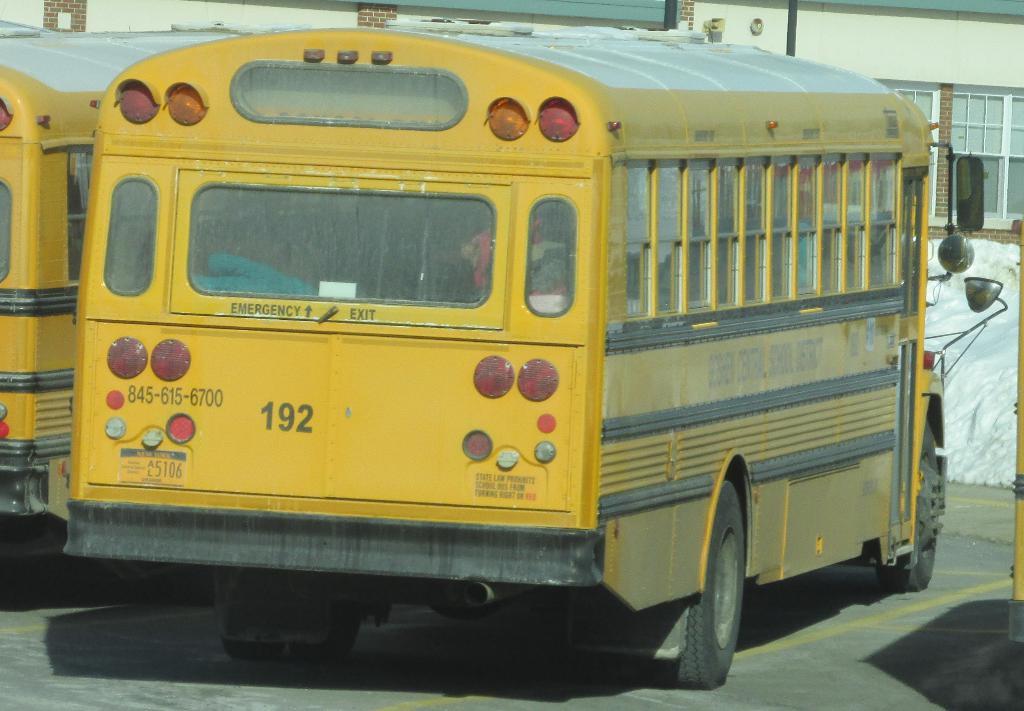What is the number on the rear of the bus?
Your answer should be compact. 192. 